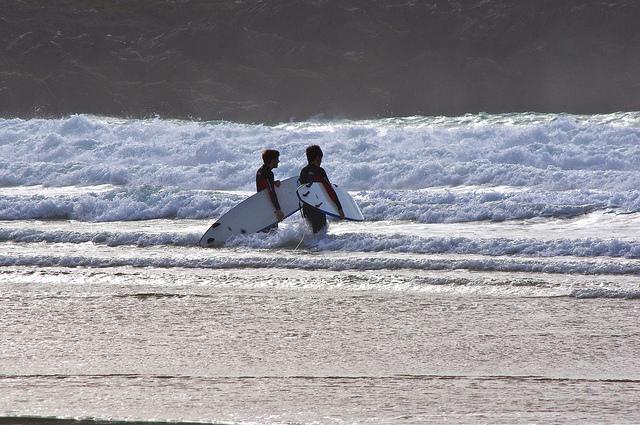What are the two men walking in?
Indicate the correct response and explain using: 'Answer: answer
Rationale: rationale.'
Options: Surf, desert, river, meadow. Answer: surf.
Rationale: The men are surfing. 